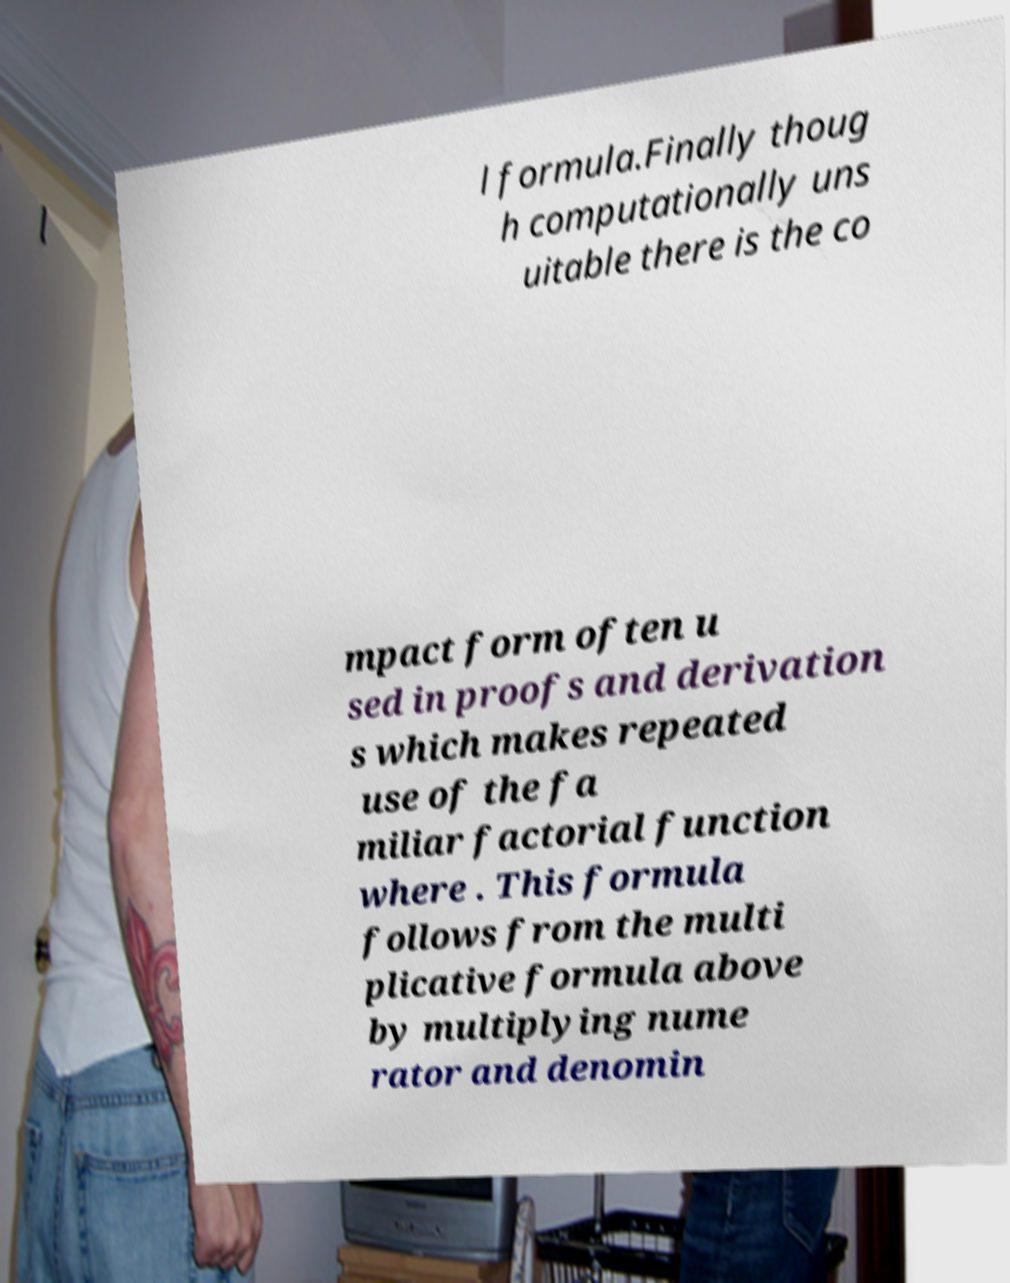Could you assist in decoding the text presented in this image and type it out clearly? l formula.Finally thoug h computationally uns uitable there is the co mpact form often u sed in proofs and derivation s which makes repeated use of the fa miliar factorial function where . This formula follows from the multi plicative formula above by multiplying nume rator and denomin 